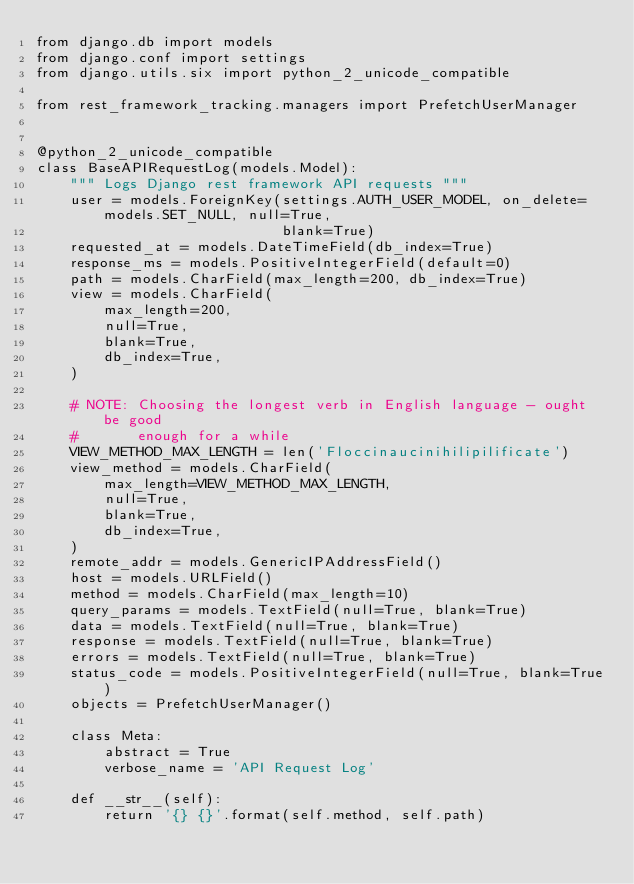Convert code to text. <code><loc_0><loc_0><loc_500><loc_500><_Python_>from django.db import models
from django.conf import settings
from django.utils.six import python_2_unicode_compatible

from rest_framework_tracking.managers import PrefetchUserManager


@python_2_unicode_compatible
class BaseAPIRequestLog(models.Model):
    """ Logs Django rest framework API requests """
    user = models.ForeignKey(settings.AUTH_USER_MODEL, on_delete=models.SET_NULL, null=True,
                             blank=True)
    requested_at = models.DateTimeField(db_index=True)
    response_ms = models.PositiveIntegerField(default=0)
    path = models.CharField(max_length=200, db_index=True)
    view = models.CharField(
        max_length=200,
        null=True,
        blank=True,
        db_index=True,
    )

    # NOTE: Choosing the longest verb in English language - ought be good
    #       enough for a while
    VIEW_METHOD_MAX_LENGTH = len('Floccinaucinihilipilificate')
    view_method = models.CharField(
        max_length=VIEW_METHOD_MAX_LENGTH,
        null=True,
        blank=True,
        db_index=True,
    )
    remote_addr = models.GenericIPAddressField()
    host = models.URLField()
    method = models.CharField(max_length=10)
    query_params = models.TextField(null=True, blank=True)
    data = models.TextField(null=True, blank=True)
    response = models.TextField(null=True, blank=True)
    errors = models.TextField(null=True, blank=True)
    status_code = models.PositiveIntegerField(null=True, blank=True)
    objects = PrefetchUserManager()

    class Meta:
        abstract = True
        verbose_name = 'API Request Log'

    def __str__(self):
        return '{} {}'.format(self.method, self.path)
</code> 